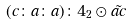Convert formula to latex. <formula><loc_0><loc_0><loc_500><loc_500>( c \colon a \colon a ) \colon 4 _ { 2 } \odot \tilde { a c }</formula> 